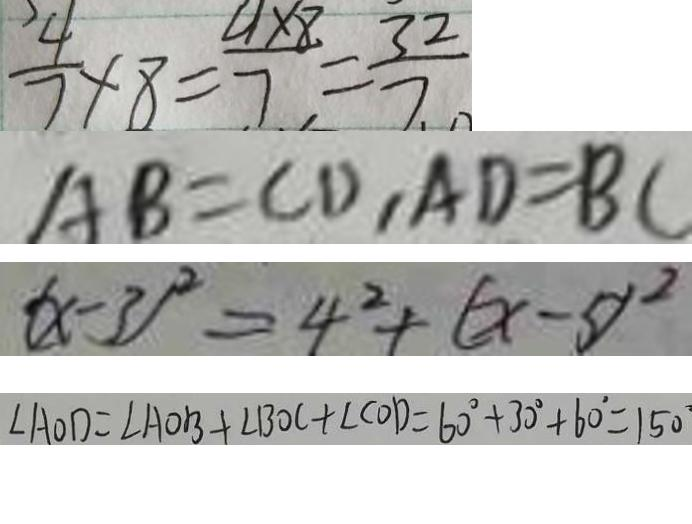<formula> <loc_0><loc_0><loc_500><loc_500>\frac { 4 } { 7 } \times 8 = \frac { 4 \times 8 } { 7 } = \frac { 3 2 } { 7 } 
 A B = C D , A D = B C 
 ( x - 3 ) ^ { 2 } = 4 ^ { 2 } + ( x - 5 ) ^ { 2 } 
 \angle A O D = \angle A O B + \angle B O C + \angle C O D = 6 0 ^ { \circ } + 3 0 ^ { \circ } + 6 0 ^ { \circ } = 1 5 0 ^ { \circ }</formula> 